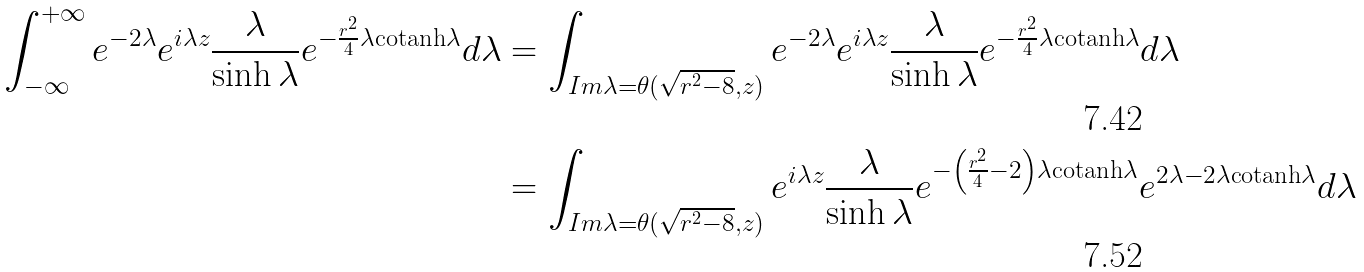<formula> <loc_0><loc_0><loc_500><loc_500>\int _ { - \infty } ^ { + \infty } e ^ { - 2 \lambda } e ^ { i \lambda z } \frac { \lambda } { \sinh \lambda } e ^ { - \frac { r ^ { 2 } } { 4 } \lambda \text {cotanh} \lambda } d \lambda & = \int _ { I m \lambda = \theta ( \sqrt { r ^ { 2 } - 8 } , z ) } e ^ { - 2 \lambda } e ^ { i \lambda z } \frac { \lambda } { \sinh \lambda } e ^ { - \frac { r ^ { 2 } } { 4 } \lambda \text {cotanh} \lambda } d \lambda \\ & = \int _ { I m \lambda = \theta ( \sqrt { r ^ { 2 } - 8 } , z ) } e ^ { i \lambda z } \frac { \lambda } { \sinh \lambda } e ^ { - \left ( \frac { r ^ { 2 } } { 4 } - 2 \right ) \lambda \text {cotanh} \lambda } e ^ { 2 \lambda - 2 \lambda \text {cotanh} \lambda } d \lambda</formula> 